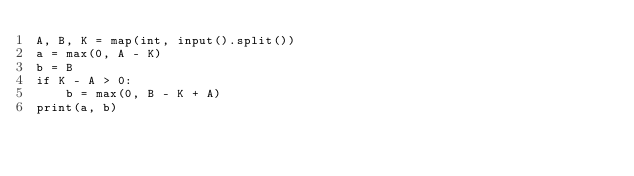Convert code to text. <code><loc_0><loc_0><loc_500><loc_500><_Python_>A, B, K = map(int, input().split())
a = max(0, A - K)
b = B
if K - A > 0:
    b = max(0, B - K + A)
print(a, b)
</code> 